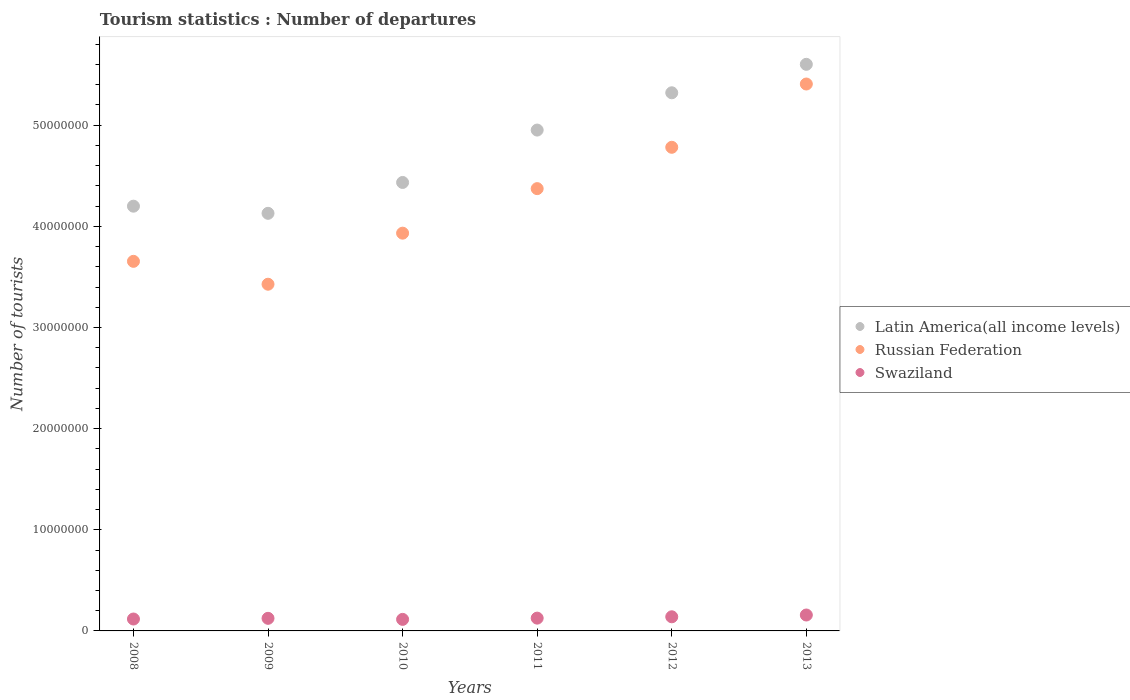How many different coloured dotlines are there?
Provide a short and direct response. 3. What is the number of tourist departures in Swaziland in 2011?
Provide a short and direct response. 1.26e+06. Across all years, what is the maximum number of tourist departures in Swaziland?
Offer a very short reply. 1.57e+06. Across all years, what is the minimum number of tourist departures in Latin America(all income levels)?
Provide a succinct answer. 4.13e+07. In which year was the number of tourist departures in Russian Federation maximum?
Offer a very short reply. 2013. What is the total number of tourist departures in Russian Federation in the graph?
Your answer should be very brief. 2.56e+08. What is the difference between the number of tourist departures in Swaziland in 2011 and that in 2013?
Make the answer very short. -3.09e+05. What is the difference between the number of tourist departures in Swaziland in 2008 and the number of tourist departures in Russian Federation in 2010?
Offer a very short reply. -3.81e+07. What is the average number of tourist departures in Russian Federation per year?
Offer a very short reply. 4.26e+07. In the year 2011, what is the difference between the number of tourist departures in Latin America(all income levels) and number of tourist departures in Russian Federation?
Ensure brevity in your answer.  5.79e+06. In how many years, is the number of tourist departures in Russian Federation greater than 14000000?
Provide a succinct answer. 6. What is the ratio of the number of tourist departures in Russian Federation in 2008 to that in 2013?
Give a very brief answer. 0.68. Is the number of tourist departures in Swaziland in 2012 less than that in 2013?
Offer a terse response. Yes. What is the difference between the highest and the second highest number of tourist departures in Latin America(all income levels)?
Your response must be concise. 2.81e+06. What is the difference between the highest and the lowest number of tourist departures in Swaziland?
Give a very brief answer. 4.32e+05. In how many years, is the number of tourist departures in Swaziland greater than the average number of tourist departures in Swaziland taken over all years?
Keep it short and to the point. 2. Is the sum of the number of tourist departures in Swaziland in 2010 and 2012 greater than the maximum number of tourist departures in Latin America(all income levels) across all years?
Your answer should be very brief. No. Is it the case that in every year, the sum of the number of tourist departures in Latin America(all income levels) and number of tourist departures in Russian Federation  is greater than the number of tourist departures in Swaziland?
Provide a short and direct response. Yes. Does the number of tourist departures in Swaziland monotonically increase over the years?
Your response must be concise. No. Is the number of tourist departures in Latin America(all income levels) strictly greater than the number of tourist departures in Swaziland over the years?
Offer a terse response. Yes. Is the number of tourist departures in Swaziland strictly less than the number of tourist departures in Latin America(all income levels) over the years?
Your answer should be compact. Yes. What is the difference between two consecutive major ticks on the Y-axis?
Ensure brevity in your answer.  1.00e+07. Are the values on the major ticks of Y-axis written in scientific E-notation?
Make the answer very short. No. How many legend labels are there?
Provide a succinct answer. 3. What is the title of the graph?
Your response must be concise. Tourism statistics : Number of departures. What is the label or title of the Y-axis?
Give a very brief answer. Number of tourists. What is the Number of tourists in Latin America(all income levels) in 2008?
Give a very brief answer. 4.20e+07. What is the Number of tourists in Russian Federation in 2008?
Your answer should be very brief. 3.65e+07. What is the Number of tourists of Swaziland in 2008?
Your response must be concise. 1.18e+06. What is the Number of tourists of Latin America(all income levels) in 2009?
Offer a very short reply. 4.13e+07. What is the Number of tourists in Russian Federation in 2009?
Keep it short and to the point. 3.43e+07. What is the Number of tourists in Swaziland in 2009?
Provide a succinct answer. 1.24e+06. What is the Number of tourists of Latin America(all income levels) in 2010?
Provide a short and direct response. 4.43e+07. What is the Number of tourists in Russian Federation in 2010?
Make the answer very short. 3.93e+07. What is the Number of tourists in Swaziland in 2010?
Provide a succinct answer. 1.14e+06. What is the Number of tourists in Latin America(all income levels) in 2011?
Provide a succinct answer. 4.95e+07. What is the Number of tourists of Russian Federation in 2011?
Provide a succinct answer. 4.37e+07. What is the Number of tourists in Swaziland in 2011?
Your answer should be very brief. 1.26e+06. What is the Number of tourists of Latin America(all income levels) in 2012?
Your response must be concise. 5.32e+07. What is the Number of tourists in Russian Federation in 2012?
Your answer should be compact. 4.78e+07. What is the Number of tourists of Swaziland in 2012?
Offer a terse response. 1.40e+06. What is the Number of tourists of Latin America(all income levels) in 2013?
Your answer should be very brief. 5.60e+07. What is the Number of tourists in Russian Federation in 2013?
Ensure brevity in your answer.  5.41e+07. What is the Number of tourists of Swaziland in 2013?
Provide a succinct answer. 1.57e+06. Across all years, what is the maximum Number of tourists of Latin America(all income levels)?
Give a very brief answer. 5.60e+07. Across all years, what is the maximum Number of tourists of Russian Federation?
Your answer should be compact. 5.41e+07. Across all years, what is the maximum Number of tourists of Swaziland?
Your answer should be compact. 1.57e+06. Across all years, what is the minimum Number of tourists in Latin America(all income levels)?
Give a very brief answer. 4.13e+07. Across all years, what is the minimum Number of tourists of Russian Federation?
Make the answer very short. 3.43e+07. Across all years, what is the minimum Number of tourists of Swaziland?
Your response must be concise. 1.14e+06. What is the total Number of tourists of Latin America(all income levels) in the graph?
Your answer should be very brief. 2.86e+08. What is the total Number of tourists of Russian Federation in the graph?
Make the answer very short. 2.56e+08. What is the total Number of tourists in Swaziland in the graph?
Your answer should be compact. 7.80e+06. What is the difference between the Number of tourists in Latin America(all income levels) in 2008 and that in 2009?
Give a very brief answer. 7.06e+05. What is the difference between the Number of tourists of Russian Federation in 2008 and that in 2009?
Your response must be concise. 2.26e+06. What is the difference between the Number of tourists in Swaziland in 2008 and that in 2009?
Ensure brevity in your answer.  -6.80e+04. What is the difference between the Number of tourists of Latin America(all income levels) in 2008 and that in 2010?
Offer a very short reply. -2.34e+06. What is the difference between the Number of tourists in Russian Federation in 2008 and that in 2010?
Your answer should be very brief. -2.78e+06. What is the difference between the Number of tourists of Swaziland in 2008 and that in 2010?
Offer a very short reply. 3.60e+04. What is the difference between the Number of tourists in Latin America(all income levels) in 2008 and that in 2011?
Offer a terse response. -7.52e+06. What is the difference between the Number of tourists of Russian Federation in 2008 and that in 2011?
Offer a very short reply. -7.19e+06. What is the difference between the Number of tourists of Swaziland in 2008 and that in 2011?
Provide a succinct answer. -8.70e+04. What is the difference between the Number of tourists of Latin America(all income levels) in 2008 and that in 2012?
Ensure brevity in your answer.  -1.12e+07. What is the difference between the Number of tourists in Russian Federation in 2008 and that in 2012?
Provide a short and direct response. -1.13e+07. What is the difference between the Number of tourists of Latin America(all income levels) in 2008 and that in 2013?
Provide a succinct answer. -1.40e+07. What is the difference between the Number of tourists of Russian Federation in 2008 and that in 2013?
Ensure brevity in your answer.  -1.75e+07. What is the difference between the Number of tourists in Swaziland in 2008 and that in 2013?
Provide a short and direct response. -3.96e+05. What is the difference between the Number of tourists in Latin America(all income levels) in 2009 and that in 2010?
Provide a succinct answer. -3.05e+06. What is the difference between the Number of tourists of Russian Federation in 2009 and that in 2010?
Keep it short and to the point. -5.05e+06. What is the difference between the Number of tourists of Swaziland in 2009 and that in 2010?
Your answer should be very brief. 1.04e+05. What is the difference between the Number of tourists of Latin America(all income levels) in 2009 and that in 2011?
Ensure brevity in your answer.  -8.23e+06. What is the difference between the Number of tourists of Russian Federation in 2009 and that in 2011?
Make the answer very short. -9.45e+06. What is the difference between the Number of tourists in Swaziland in 2009 and that in 2011?
Offer a very short reply. -1.90e+04. What is the difference between the Number of tourists in Latin America(all income levels) in 2009 and that in 2012?
Provide a succinct answer. -1.19e+07. What is the difference between the Number of tourists of Russian Federation in 2009 and that in 2012?
Offer a very short reply. -1.35e+07. What is the difference between the Number of tourists of Swaziland in 2009 and that in 2012?
Provide a succinct answer. -1.52e+05. What is the difference between the Number of tourists in Latin America(all income levels) in 2009 and that in 2013?
Provide a succinct answer. -1.47e+07. What is the difference between the Number of tourists in Russian Federation in 2009 and that in 2013?
Make the answer very short. -1.98e+07. What is the difference between the Number of tourists of Swaziland in 2009 and that in 2013?
Your answer should be very brief. -3.28e+05. What is the difference between the Number of tourists in Latin America(all income levels) in 2010 and that in 2011?
Ensure brevity in your answer.  -5.18e+06. What is the difference between the Number of tourists of Russian Federation in 2010 and that in 2011?
Keep it short and to the point. -4.40e+06. What is the difference between the Number of tourists in Swaziland in 2010 and that in 2011?
Offer a very short reply. -1.23e+05. What is the difference between the Number of tourists in Latin America(all income levels) in 2010 and that in 2012?
Offer a very short reply. -8.87e+06. What is the difference between the Number of tourists of Russian Federation in 2010 and that in 2012?
Provide a short and direct response. -8.49e+06. What is the difference between the Number of tourists of Swaziland in 2010 and that in 2012?
Your response must be concise. -2.56e+05. What is the difference between the Number of tourists of Latin America(all income levels) in 2010 and that in 2013?
Your response must be concise. -1.17e+07. What is the difference between the Number of tourists in Russian Federation in 2010 and that in 2013?
Provide a short and direct response. -1.47e+07. What is the difference between the Number of tourists of Swaziland in 2010 and that in 2013?
Ensure brevity in your answer.  -4.32e+05. What is the difference between the Number of tourists in Latin America(all income levels) in 2011 and that in 2012?
Your answer should be compact. -3.69e+06. What is the difference between the Number of tourists of Russian Federation in 2011 and that in 2012?
Provide a succinct answer. -4.09e+06. What is the difference between the Number of tourists in Swaziland in 2011 and that in 2012?
Your response must be concise. -1.33e+05. What is the difference between the Number of tourists in Latin America(all income levels) in 2011 and that in 2013?
Your response must be concise. -6.50e+06. What is the difference between the Number of tourists in Russian Federation in 2011 and that in 2013?
Offer a terse response. -1.03e+07. What is the difference between the Number of tourists of Swaziland in 2011 and that in 2013?
Give a very brief answer. -3.09e+05. What is the difference between the Number of tourists in Latin America(all income levels) in 2012 and that in 2013?
Keep it short and to the point. -2.81e+06. What is the difference between the Number of tourists in Russian Federation in 2012 and that in 2013?
Keep it short and to the point. -6.26e+06. What is the difference between the Number of tourists in Swaziland in 2012 and that in 2013?
Make the answer very short. -1.76e+05. What is the difference between the Number of tourists of Latin America(all income levels) in 2008 and the Number of tourists of Russian Federation in 2009?
Give a very brief answer. 7.72e+06. What is the difference between the Number of tourists in Latin America(all income levels) in 2008 and the Number of tourists in Swaziland in 2009?
Make the answer very short. 4.07e+07. What is the difference between the Number of tourists of Russian Federation in 2008 and the Number of tourists of Swaziland in 2009?
Provide a short and direct response. 3.53e+07. What is the difference between the Number of tourists in Latin America(all income levels) in 2008 and the Number of tourists in Russian Federation in 2010?
Provide a succinct answer. 2.67e+06. What is the difference between the Number of tourists of Latin America(all income levels) in 2008 and the Number of tourists of Swaziland in 2010?
Ensure brevity in your answer.  4.09e+07. What is the difference between the Number of tourists of Russian Federation in 2008 and the Number of tourists of Swaziland in 2010?
Your response must be concise. 3.54e+07. What is the difference between the Number of tourists of Latin America(all income levels) in 2008 and the Number of tourists of Russian Federation in 2011?
Offer a very short reply. -1.73e+06. What is the difference between the Number of tourists in Latin America(all income levels) in 2008 and the Number of tourists in Swaziland in 2011?
Ensure brevity in your answer.  4.07e+07. What is the difference between the Number of tourists in Russian Federation in 2008 and the Number of tourists in Swaziland in 2011?
Make the answer very short. 3.53e+07. What is the difference between the Number of tourists in Latin America(all income levels) in 2008 and the Number of tourists in Russian Federation in 2012?
Offer a terse response. -5.82e+06. What is the difference between the Number of tourists in Latin America(all income levels) in 2008 and the Number of tourists in Swaziland in 2012?
Your answer should be very brief. 4.06e+07. What is the difference between the Number of tourists in Russian Federation in 2008 and the Number of tourists in Swaziland in 2012?
Your answer should be very brief. 3.51e+07. What is the difference between the Number of tourists of Latin America(all income levels) in 2008 and the Number of tourists of Russian Federation in 2013?
Ensure brevity in your answer.  -1.21e+07. What is the difference between the Number of tourists in Latin America(all income levels) in 2008 and the Number of tourists in Swaziland in 2013?
Your answer should be very brief. 4.04e+07. What is the difference between the Number of tourists in Russian Federation in 2008 and the Number of tourists in Swaziland in 2013?
Ensure brevity in your answer.  3.50e+07. What is the difference between the Number of tourists of Latin America(all income levels) in 2009 and the Number of tourists of Russian Federation in 2010?
Offer a very short reply. 1.96e+06. What is the difference between the Number of tourists in Latin America(all income levels) in 2009 and the Number of tourists in Swaziland in 2010?
Make the answer very short. 4.01e+07. What is the difference between the Number of tourists of Russian Federation in 2009 and the Number of tourists of Swaziland in 2010?
Keep it short and to the point. 3.31e+07. What is the difference between the Number of tourists in Latin America(all income levels) in 2009 and the Number of tourists in Russian Federation in 2011?
Make the answer very short. -2.44e+06. What is the difference between the Number of tourists in Latin America(all income levels) in 2009 and the Number of tourists in Swaziland in 2011?
Keep it short and to the point. 4.00e+07. What is the difference between the Number of tourists in Russian Federation in 2009 and the Number of tourists in Swaziland in 2011?
Provide a succinct answer. 3.30e+07. What is the difference between the Number of tourists of Latin America(all income levels) in 2009 and the Number of tourists of Russian Federation in 2012?
Offer a very short reply. -6.53e+06. What is the difference between the Number of tourists in Latin America(all income levels) in 2009 and the Number of tourists in Swaziland in 2012?
Provide a succinct answer. 3.99e+07. What is the difference between the Number of tourists in Russian Federation in 2009 and the Number of tourists in Swaziland in 2012?
Offer a terse response. 3.29e+07. What is the difference between the Number of tourists in Latin America(all income levels) in 2009 and the Number of tourists in Russian Federation in 2013?
Your answer should be compact. -1.28e+07. What is the difference between the Number of tourists in Latin America(all income levels) in 2009 and the Number of tourists in Swaziland in 2013?
Keep it short and to the point. 3.97e+07. What is the difference between the Number of tourists of Russian Federation in 2009 and the Number of tourists of Swaziland in 2013?
Provide a short and direct response. 3.27e+07. What is the difference between the Number of tourists in Latin America(all income levels) in 2010 and the Number of tourists in Russian Federation in 2011?
Offer a very short reply. 6.10e+05. What is the difference between the Number of tourists of Latin America(all income levels) in 2010 and the Number of tourists of Swaziland in 2011?
Keep it short and to the point. 4.31e+07. What is the difference between the Number of tourists of Russian Federation in 2010 and the Number of tourists of Swaziland in 2011?
Provide a short and direct response. 3.81e+07. What is the difference between the Number of tourists in Latin America(all income levels) in 2010 and the Number of tourists in Russian Federation in 2012?
Give a very brief answer. -3.48e+06. What is the difference between the Number of tourists of Latin America(all income levels) in 2010 and the Number of tourists of Swaziland in 2012?
Give a very brief answer. 4.29e+07. What is the difference between the Number of tourists of Russian Federation in 2010 and the Number of tourists of Swaziland in 2012?
Your answer should be compact. 3.79e+07. What is the difference between the Number of tourists in Latin America(all income levels) in 2010 and the Number of tourists in Russian Federation in 2013?
Ensure brevity in your answer.  -9.73e+06. What is the difference between the Number of tourists of Latin America(all income levels) in 2010 and the Number of tourists of Swaziland in 2013?
Provide a succinct answer. 4.28e+07. What is the difference between the Number of tourists in Russian Federation in 2010 and the Number of tourists in Swaziland in 2013?
Your answer should be very brief. 3.78e+07. What is the difference between the Number of tourists in Latin America(all income levels) in 2011 and the Number of tourists in Russian Federation in 2012?
Offer a terse response. 1.70e+06. What is the difference between the Number of tourists of Latin America(all income levels) in 2011 and the Number of tourists of Swaziland in 2012?
Keep it short and to the point. 4.81e+07. What is the difference between the Number of tourists of Russian Federation in 2011 and the Number of tourists of Swaziland in 2012?
Ensure brevity in your answer.  4.23e+07. What is the difference between the Number of tourists in Latin America(all income levels) in 2011 and the Number of tourists in Russian Federation in 2013?
Make the answer very short. -4.55e+06. What is the difference between the Number of tourists of Latin America(all income levels) in 2011 and the Number of tourists of Swaziland in 2013?
Make the answer very short. 4.79e+07. What is the difference between the Number of tourists of Russian Federation in 2011 and the Number of tourists of Swaziland in 2013?
Offer a very short reply. 4.22e+07. What is the difference between the Number of tourists of Latin America(all income levels) in 2012 and the Number of tourists of Russian Federation in 2013?
Your response must be concise. -8.67e+05. What is the difference between the Number of tourists in Latin America(all income levels) in 2012 and the Number of tourists in Swaziland in 2013?
Your answer should be compact. 5.16e+07. What is the difference between the Number of tourists in Russian Federation in 2012 and the Number of tourists in Swaziland in 2013?
Your answer should be very brief. 4.62e+07. What is the average Number of tourists in Latin America(all income levels) per year?
Make the answer very short. 4.77e+07. What is the average Number of tourists of Russian Federation per year?
Your answer should be very brief. 4.26e+07. What is the average Number of tourists of Swaziland per year?
Provide a succinct answer. 1.30e+06. In the year 2008, what is the difference between the Number of tourists of Latin America(all income levels) and Number of tourists of Russian Federation?
Your response must be concise. 5.45e+06. In the year 2008, what is the difference between the Number of tourists of Latin America(all income levels) and Number of tourists of Swaziland?
Ensure brevity in your answer.  4.08e+07. In the year 2008, what is the difference between the Number of tourists in Russian Federation and Number of tourists in Swaziland?
Make the answer very short. 3.54e+07. In the year 2009, what is the difference between the Number of tourists in Latin America(all income levels) and Number of tourists in Russian Federation?
Give a very brief answer. 7.01e+06. In the year 2009, what is the difference between the Number of tourists of Latin America(all income levels) and Number of tourists of Swaziland?
Make the answer very short. 4.00e+07. In the year 2009, what is the difference between the Number of tourists in Russian Federation and Number of tourists in Swaziland?
Your answer should be very brief. 3.30e+07. In the year 2010, what is the difference between the Number of tourists in Latin America(all income levels) and Number of tourists in Russian Federation?
Provide a succinct answer. 5.01e+06. In the year 2010, what is the difference between the Number of tourists of Latin America(all income levels) and Number of tourists of Swaziland?
Keep it short and to the point. 4.32e+07. In the year 2010, what is the difference between the Number of tourists of Russian Federation and Number of tourists of Swaziland?
Offer a terse response. 3.82e+07. In the year 2011, what is the difference between the Number of tourists of Latin America(all income levels) and Number of tourists of Russian Federation?
Give a very brief answer. 5.79e+06. In the year 2011, what is the difference between the Number of tourists in Latin America(all income levels) and Number of tourists in Swaziland?
Your answer should be compact. 4.83e+07. In the year 2011, what is the difference between the Number of tourists of Russian Federation and Number of tourists of Swaziland?
Provide a short and direct response. 4.25e+07. In the year 2012, what is the difference between the Number of tourists of Latin America(all income levels) and Number of tourists of Russian Federation?
Your answer should be compact. 5.39e+06. In the year 2012, what is the difference between the Number of tourists of Latin America(all income levels) and Number of tourists of Swaziland?
Give a very brief answer. 5.18e+07. In the year 2012, what is the difference between the Number of tourists of Russian Federation and Number of tourists of Swaziland?
Ensure brevity in your answer.  4.64e+07. In the year 2013, what is the difference between the Number of tourists in Latin America(all income levels) and Number of tourists in Russian Federation?
Your answer should be compact. 1.95e+06. In the year 2013, what is the difference between the Number of tourists in Latin America(all income levels) and Number of tourists in Swaziland?
Offer a very short reply. 5.44e+07. In the year 2013, what is the difference between the Number of tourists in Russian Federation and Number of tourists in Swaziland?
Offer a terse response. 5.25e+07. What is the ratio of the Number of tourists in Latin America(all income levels) in 2008 to that in 2009?
Offer a very short reply. 1.02. What is the ratio of the Number of tourists of Russian Federation in 2008 to that in 2009?
Provide a short and direct response. 1.07. What is the ratio of the Number of tourists of Swaziland in 2008 to that in 2009?
Give a very brief answer. 0.95. What is the ratio of the Number of tourists in Latin America(all income levels) in 2008 to that in 2010?
Make the answer very short. 0.95. What is the ratio of the Number of tourists in Russian Federation in 2008 to that in 2010?
Your answer should be very brief. 0.93. What is the ratio of the Number of tourists of Swaziland in 2008 to that in 2010?
Your answer should be very brief. 1.03. What is the ratio of the Number of tourists of Latin America(all income levels) in 2008 to that in 2011?
Your response must be concise. 0.85. What is the ratio of the Number of tourists of Russian Federation in 2008 to that in 2011?
Keep it short and to the point. 0.84. What is the ratio of the Number of tourists in Swaziland in 2008 to that in 2011?
Ensure brevity in your answer.  0.93. What is the ratio of the Number of tourists in Latin America(all income levels) in 2008 to that in 2012?
Provide a succinct answer. 0.79. What is the ratio of the Number of tourists in Russian Federation in 2008 to that in 2012?
Offer a very short reply. 0.76. What is the ratio of the Number of tourists of Swaziland in 2008 to that in 2012?
Provide a short and direct response. 0.84. What is the ratio of the Number of tourists of Latin America(all income levels) in 2008 to that in 2013?
Ensure brevity in your answer.  0.75. What is the ratio of the Number of tourists of Russian Federation in 2008 to that in 2013?
Provide a short and direct response. 0.68. What is the ratio of the Number of tourists in Swaziland in 2008 to that in 2013?
Your answer should be compact. 0.75. What is the ratio of the Number of tourists in Latin America(all income levels) in 2009 to that in 2010?
Provide a short and direct response. 0.93. What is the ratio of the Number of tourists of Russian Federation in 2009 to that in 2010?
Offer a terse response. 0.87. What is the ratio of the Number of tourists in Swaziland in 2009 to that in 2010?
Your response must be concise. 1.09. What is the ratio of the Number of tourists of Latin America(all income levels) in 2009 to that in 2011?
Your answer should be compact. 0.83. What is the ratio of the Number of tourists in Russian Federation in 2009 to that in 2011?
Provide a short and direct response. 0.78. What is the ratio of the Number of tourists in Swaziland in 2009 to that in 2011?
Keep it short and to the point. 0.98. What is the ratio of the Number of tourists in Latin America(all income levels) in 2009 to that in 2012?
Provide a succinct answer. 0.78. What is the ratio of the Number of tourists in Russian Federation in 2009 to that in 2012?
Ensure brevity in your answer.  0.72. What is the ratio of the Number of tourists of Swaziland in 2009 to that in 2012?
Provide a short and direct response. 0.89. What is the ratio of the Number of tourists in Latin America(all income levels) in 2009 to that in 2013?
Your answer should be compact. 0.74. What is the ratio of the Number of tourists of Russian Federation in 2009 to that in 2013?
Provide a short and direct response. 0.63. What is the ratio of the Number of tourists in Swaziland in 2009 to that in 2013?
Offer a terse response. 0.79. What is the ratio of the Number of tourists of Latin America(all income levels) in 2010 to that in 2011?
Provide a short and direct response. 0.9. What is the ratio of the Number of tourists in Russian Federation in 2010 to that in 2011?
Give a very brief answer. 0.9. What is the ratio of the Number of tourists in Swaziland in 2010 to that in 2011?
Give a very brief answer. 0.9. What is the ratio of the Number of tourists in Russian Federation in 2010 to that in 2012?
Keep it short and to the point. 0.82. What is the ratio of the Number of tourists in Swaziland in 2010 to that in 2012?
Your response must be concise. 0.82. What is the ratio of the Number of tourists of Latin America(all income levels) in 2010 to that in 2013?
Your answer should be very brief. 0.79. What is the ratio of the Number of tourists of Russian Federation in 2010 to that in 2013?
Provide a short and direct response. 0.73. What is the ratio of the Number of tourists in Swaziland in 2010 to that in 2013?
Provide a short and direct response. 0.73. What is the ratio of the Number of tourists in Latin America(all income levels) in 2011 to that in 2012?
Your response must be concise. 0.93. What is the ratio of the Number of tourists in Russian Federation in 2011 to that in 2012?
Keep it short and to the point. 0.91. What is the ratio of the Number of tourists in Swaziland in 2011 to that in 2012?
Offer a very short reply. 0.9. What is the ratio of the Number of tourists in Latin America(all income levels) in 2011 to that in 2013?
Your answer should be very brief. 0.88. What is the ratio of the Number of tourists in Russian Federation in 2011 to that in 2013?
Provide a short and direct response. 0.81. What is the ratio of the Number of tourists of Swaziland in 2011 to that in 2013?
Your answer should be very brief. 0.8. What is the ratio of the Number of tourists in Latin America(all income levels) in 2012 to that in 2013?
Your answer should be compact. 0.95. What is the ratio of the Number of tourists of Russian Federation in 2012 to that in 2013?
Give a very brief answer. 0.88. What is the ratio of the Number of tourists in Swaziland in 2012 to that in 2013?
Ensure brevity in your answer.  0.89. What is the difference between the highest and the second highest Number of tourists in Latin America(all income levels)?
Make the answer very short. 2.81e+06. What is the difference between the highest and the second highest Number of tourists of Russian Federation?
Keep it short and to the point. 6.26e+06. What is the difference between the highest and the second highest Number of tourists in Swaziland?
Provide a short and direct response. 1.76e+05. What is the difference between the highest and the lowest Number of tourists of Latin America(all income levels)?
Keep it short and to the point. 1.47e+07. What is the difference between the highest and the lowest Number of tourists of Russian Federation?
Your answer should be very brief. 1.98e+07. What is the difference between the highest and the lowest Number of tourists of Swaziland?
Offer a terse response. 4.32e+05. 